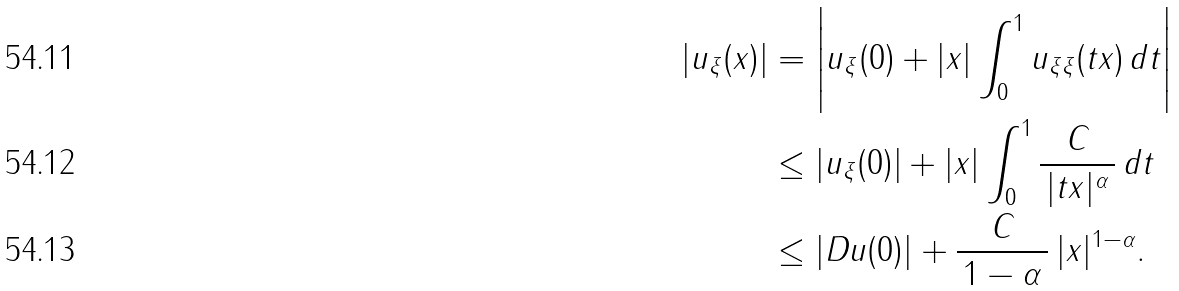<formula> <loc_0><loc_0><loc_500><loc_500>| u _ { \xi } ( x ) | & = \left | u _ { \xi } ( 0 ) + | x | \int _ { 0 } ^ { 1 } u _ { \xi \xi } ( t x ) \, d t \right | \\ & \leq | u _ { \xi } ( 0 ) | + | x | \int _ { 0 } ^ { 1 } \frac { C } { \, | t x | ^ { \alpha } \, } \, d t \\ & \leq | D u ( 0 ) | + \frac { C } { \, 1 - \alpha \, } \, | x | ^ { 1 - \alpha } .</formula> 